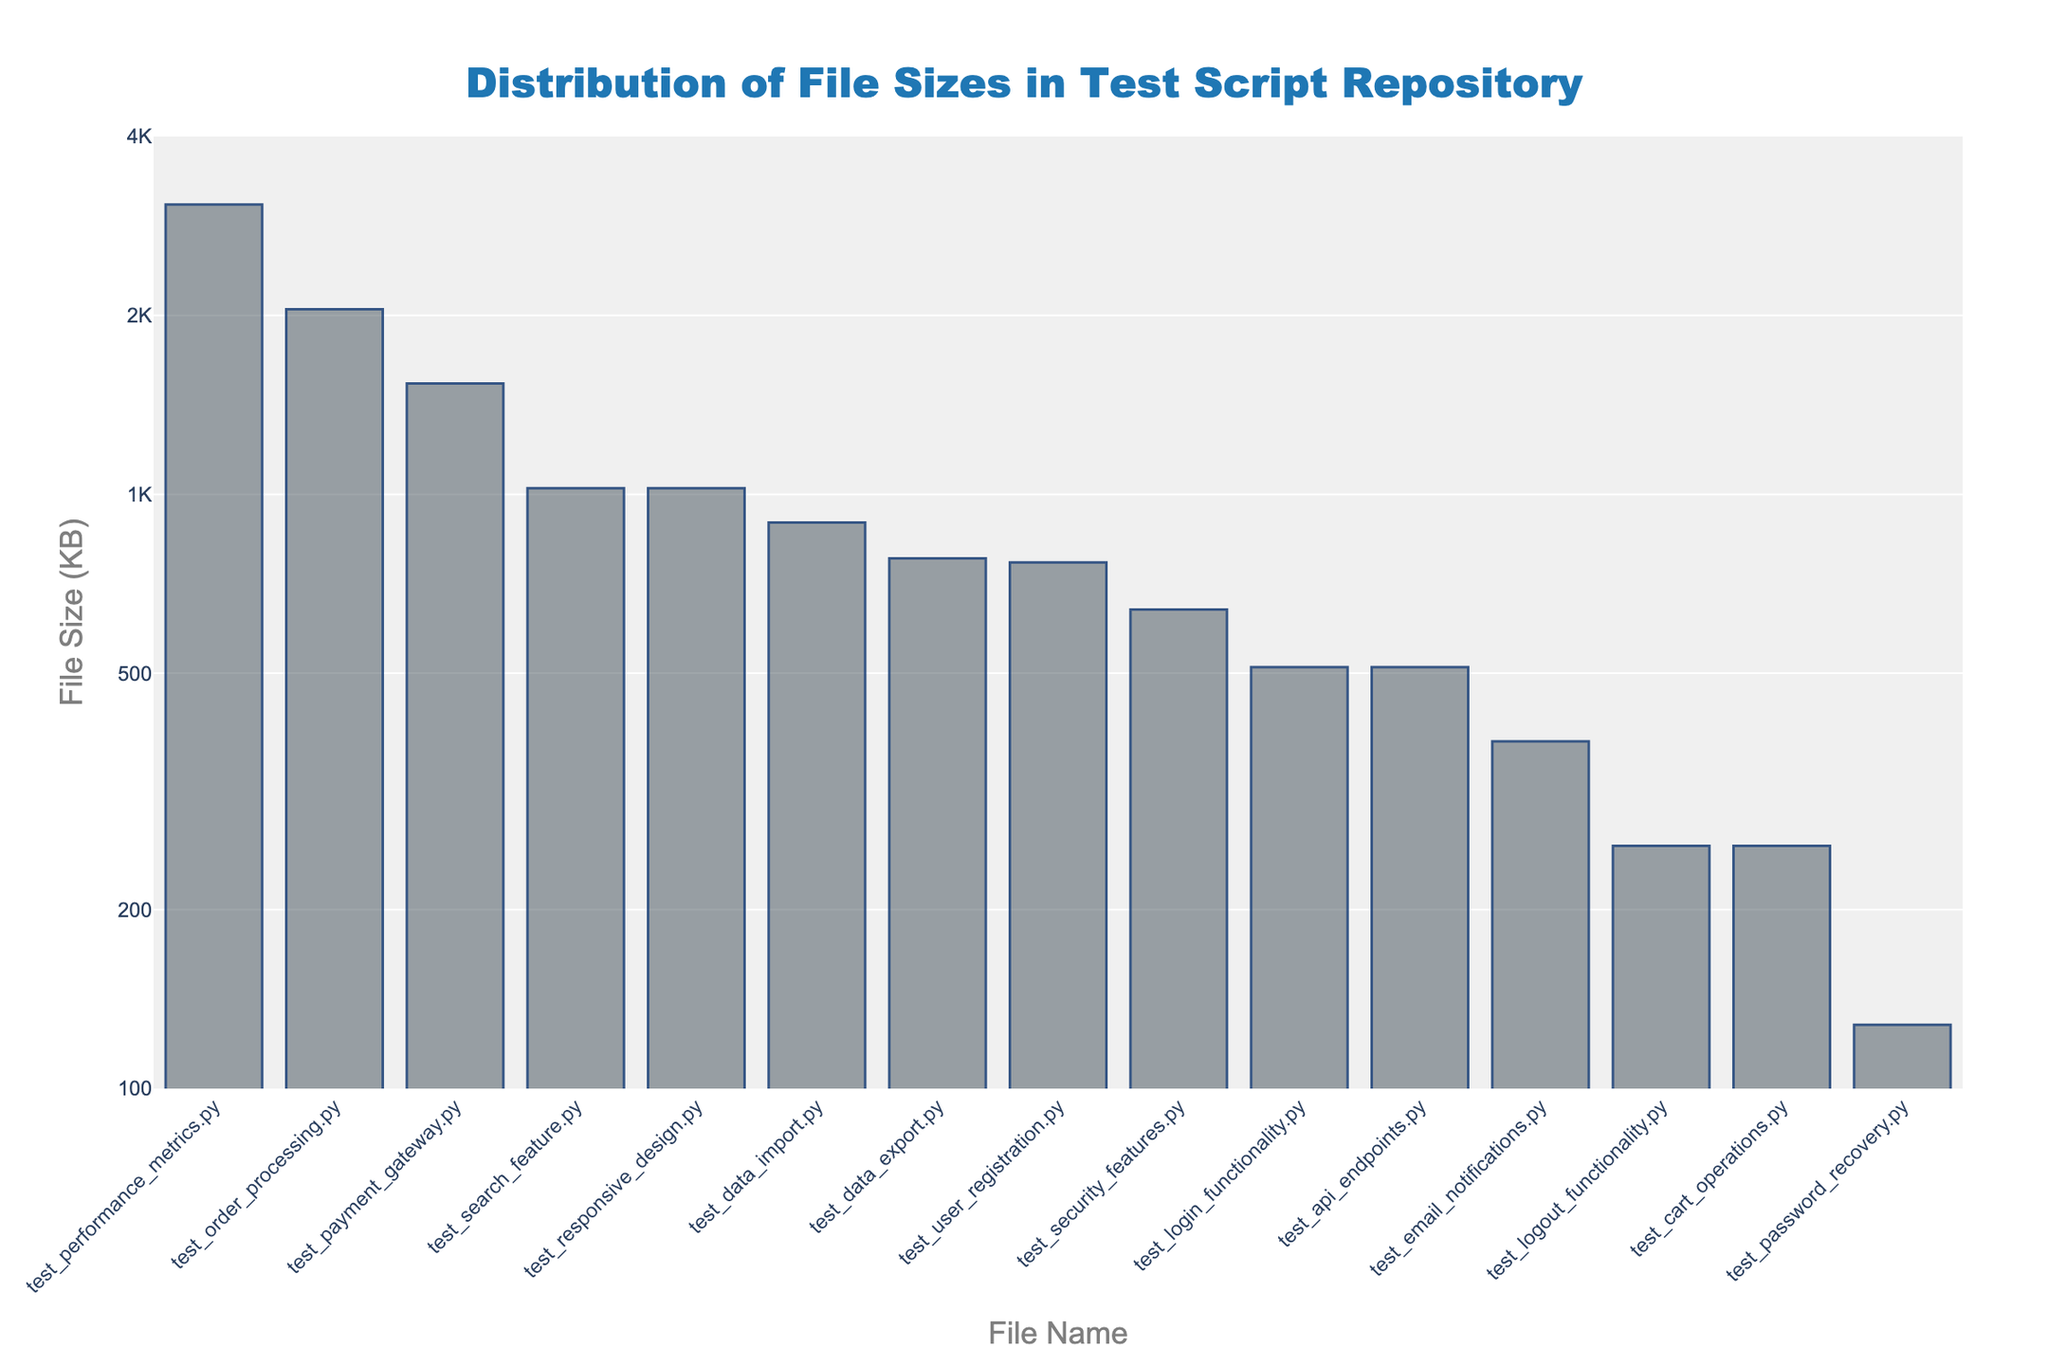Which file has the largest size? The bar plot sorts the files by size in descending order. The leftmost bar represents the largest file, 'test_performance_metrics.py' which has the highest value on the y-axis.
Answer: 'test_performance_metrics.py' What is the size of the smallest file? The rightmost bar represents the smallest file shown in the bar plot. 'test_password_recovery.py' is the smallest with a size of 128 KB based on its position on the y-axis.
Answer: 128 KB How many files are larger than 1000 KB? Files with sizes greater than 1000 KB are visible on the y-axis which is in log scale. The bars representing sizes above the 1000 KB mark are: 'test_performance_metrics.py', 'test_order_processing.py', 'test_payment_gateway.py', and 'test_search_feature.py'. Count these bars.
Answer: 4 files Which file is exactly 256 KB? Check the bars corresponding to the height of 256 KB on the log scale y-axis. There are two files: 'test_logout_functionality.py' and 'test_cart_operations.py'.
Answer: 'test_logout_functionality.py' and 'test_cart_operations.py' What is the size difference between the largest and the smallest file? The largest file size on the y-axis is 3072 KB ('test_performance_metrics.py') and the smallest is 128 KB ('test_password_recovery.py'). Subtract the smallest size from the largest. \(3072 - 128 = 2944\).
Answer: 2944 KB Which files are between 500 KB and 1000 KB? Look for the bars in the log scale graph whose heights are between the tick marks for 500 KB and 1000 KB. Identify these files: 'test_security_features.py' (640 KB), 'test_data_import.py' (896 KB), and 'test_data_export.py' (780 KB).
Answer: 'test_security_features.py', 'test_data_import.py', 'test_data_export.py' Which file is closest in size to 384 KB? Find the files near the 384 KB mark. The file 'test_email_notifications.py' has an exact size of 384 KB.
Answer: 'test_email_notifications.py' How many files have sizes under 500 KB? Identify and count the bars on the log scale y-axis that have a height of less than 500 KB: 'test_password_recovery.py', 'test_logout_functionality.py', 'test_cart_operations.py', and 'test_email_notifications.py'.
Answer: 4 files Which file sizes are represented using the largest tick on the y-axis? The highest tick on the log scale y-axis includes 4000 KB. There is no file that exactly aligns with 4000 KB, but 'test_performance_metrics.py' at 3072 KB is close to it but below.
Answer: None 